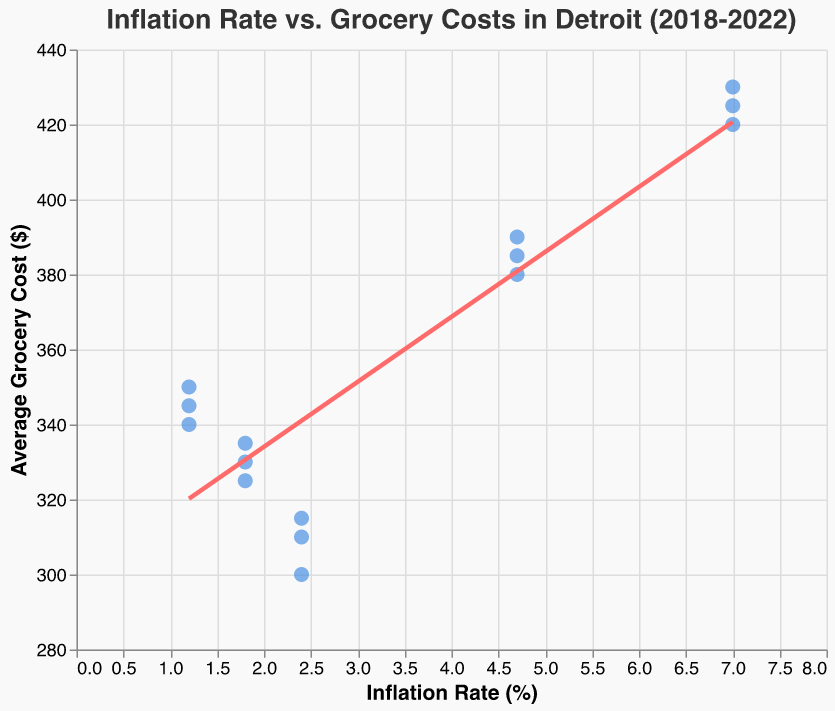What's the title of the chart? The title is written at the top of the chart and reads "Inflation Rate vs. Grocery Costs in Detroit (2018-2022)".
Answer: Inflation Rate vs. Grocery Costs in Detroit (2018-2022) How many data points are there on the plot? Count the number of points plotted; there are 15 points in total.
Answer: 15 What is the range of the Inflation Rate axis? Check the horizontal axis, which spans from 0% to 8%.
Answer: 0% to 8% What is the highest average grocery cost recorded and in which year? Identify the highest point on the vertical axis, which is $430, recorded in 2022.
Answer: $430, 2022 What trend does the trend line suggest about the relationship between inflation rate and average grocery costs? The trend line slopes upward, indicating that higher inflation rates are associated with higher average grocery costs.
Answer: Higher inflation, higher grocery costs In which year was the average grocery cost $380-$390, and what was the inflation rate then? Identify the points with average grocery costs between $380 and $390; these points exist in 2021 with an inflation rate of 4.7%.
Answer: 2021, 4.7% What is the average grocery cost for the year 2020? Identify the points for 2020 and calculate the average of $340, $350, and $345, which sum to $1035. Dividing by 3 gives us $345.
Answer: $345 How does the average grocery cost in 2022 compare to that in 2018? The range of grocery costs in 2018 is $300-$315, while in 2022 it is $420-$430, showing a significant increase in 2022 compared to 2018.
Answer: Increased At which inflation rate do the grocery costs show the greatest increase? The greatest increase in grocery costs is observed between 2020 and 2021, where inflation jumps from 1.2% to 4.7%.
Answer: From 1.2% to 4.7% What is the inflation rate when the average grocery cost is $350? Locate the point with an average grocery cost of $350, which corresponds to a 1.2% inflation rate in 2020.
Answer: 1.2% 